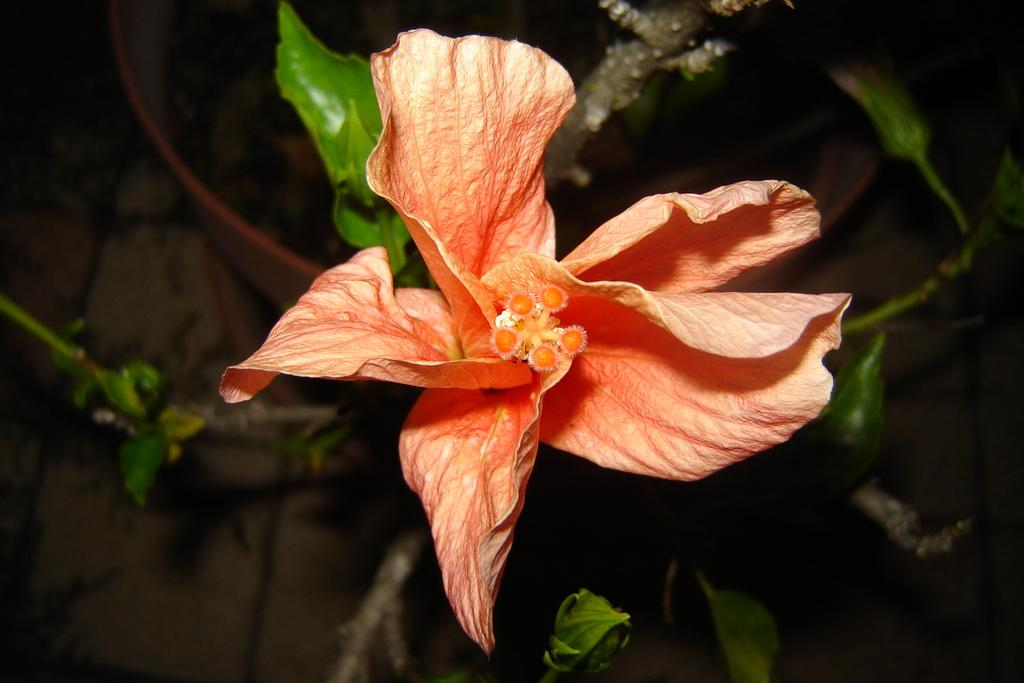What type of plant can be seen in the image? There is a flower in the image. What part of the plant is visible in the image? There are green leaves and stems in the image. What is the color of the background in the image? The background of the image is dark. Where is the nest located in the image? There is no nest present in the image. What type of waste can be seen in the image? There is no waste present in the image. 